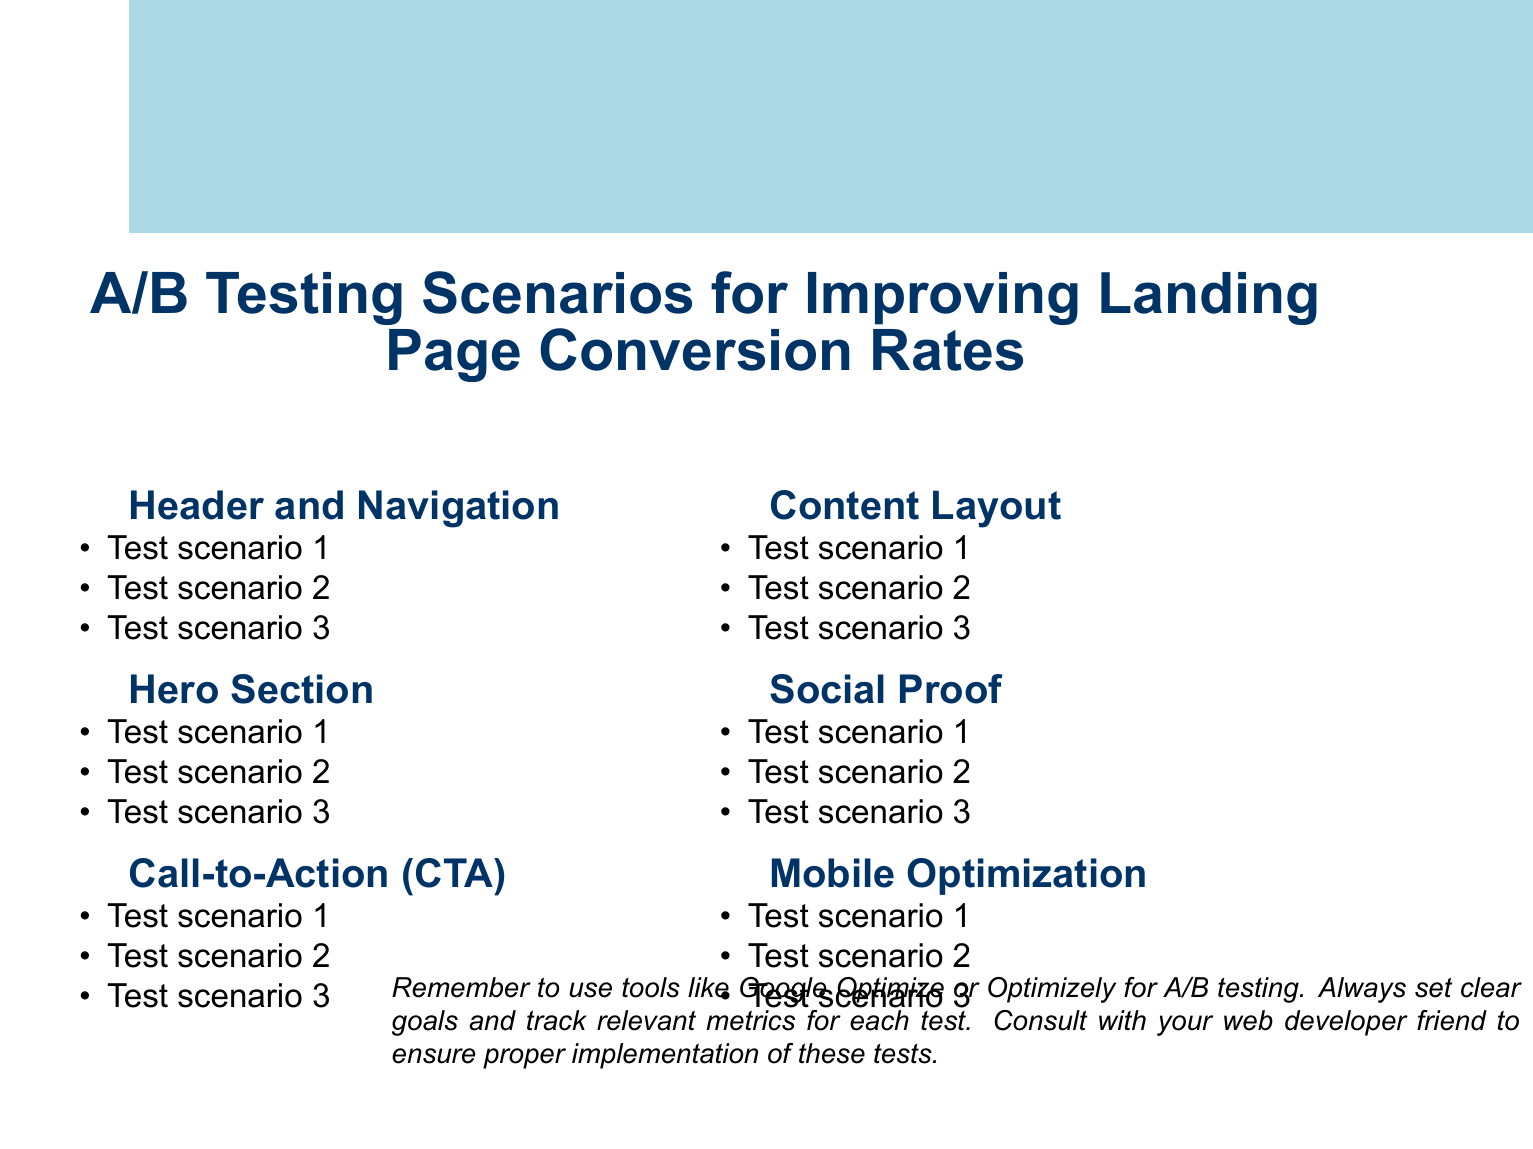What are the main sections of the document? The main sections listed in the document are Header and Navigation, Hero Section, Call-to-Action, Content Layout, Social Proof, and Mobile Optimization.
Answer: Header and Navigation, Hero Section, Call-to-Action, Content Layout, Social Proof, Mobile Optimization How many scenarios are there under Call-to-Action? The document lists three specific scenarios under the Call-to-Action section.
Answer: Three What color comparisons are tested in the button color variations? The document specifies testing the variations between green and orange button colors.
Answer: Green vs. orange Which type of proof is analyzed in the Social Proof section? The document highlights customer testimonials and case studies as forms of proof to be tested.
Answer: Customer testimonials vs. case studies What is suggested for mobile optimization tests regarding menu styles? The document mentions testing hamburger style versus bottom bar style for mobile menus.
Answer: Hamburger vs. bottom bar What is the impact of adding social proof elements being evaluated under Hero Section? The document specifies evaluating the impact of adding social proof elements to the Hero section.
Answer: Adding social proof elements How is the layout being tested in the Content Layout section? The document mentions testing a single-column layout versus a two-column layout.
Answer: Single-column vs. two-column What tool is mentioned for A/B testing in the notes? The document suggests using tools like Google Optimize or Optimizely for A/B testing.
Answer: Google Optimize or Optimizely How many sections are proposed for testing in mobile optimization? The document proposes three specific scenarios for testing mobile optimization.
Answer: Three 